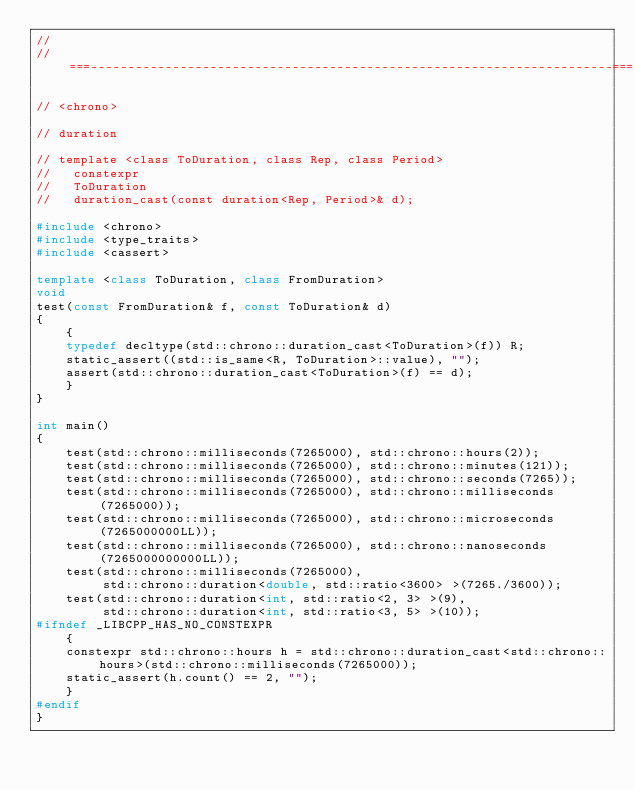Convert code to text. <code><loc_0><loc_0><loc_500><loc_500><_C++_>//
//===----------------------------------------------------------------------===//

// <chrono>

// duration

// template <class ToDuration, class Rep, class Period>
//   constexpr
//   ToDuration
//   duration_cast(const duration<Rep, Period>& d);

#include <chrono>
#include <type_traits>
#include <cassert>

template <class ToDuration, class FromDuration>
void
test(const FromDuration& f, const ToDuration& d)
{
    {
    typedef decltype(std::chrono::duration_cast<ToDuration>(f)) R;
    static_assert((std::is_same<R, ToDuration>::value), "");
    assert(std::chrono::duration_cast<ToDuration>(f) == d);
    }
}

int main()
{
    test(std::chrono::milliseconds(7265000), std::chrono::hours(2));
    test(std::chrono::milliseconds(7265000), std::chrono::minutes(121));
    test(std::chrono::milliseconds(7265000), std::chrono::seconds(7265));
    test(std::chrono::milliseconds(7265000), std::chrono::milliseconds(7265000));
    test(std::chrono::milliseconds(7265000), std::chrono::microseconds(7265000000LL));
    test(std::chrono::milliseconds(7265000), std::chrono::nanoseconds(7265000000000LL));
    test(std::chrono::milliseconds(7265000),
         std::chrono::duration<double, std::ratio<3600> >(7265./3600));
    test(std::chrono::duration<int, std::ratio<2, 3> >(9),
         std::chrono::duration<int, std::ratio<3, 5> >(10));
#ifndef _LIBCPP_HAS_NO_CONSTEXPR
    {
    constexpr std::chrono::hours h = std::chrono::duration_cast<std::chrono::hours>(std::chrono::milliseconds(7265000));
    static_assert(h.count() == 2, "");
    }
#endif
}
</code> 